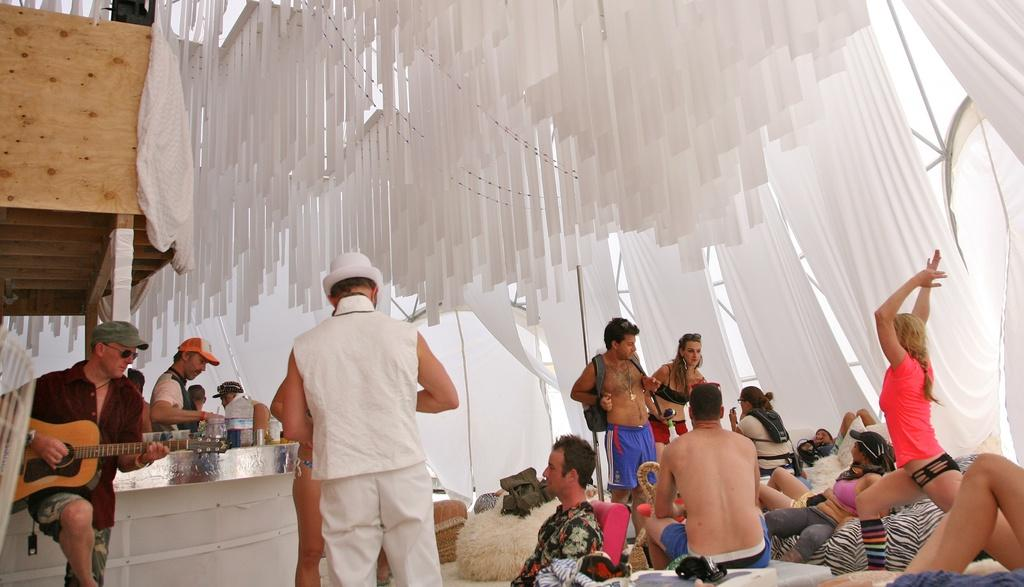How many people are in the image? There are many people in the image. What are some of the people doing in the image? Some people are sitting, while others are standing. Can you describe any specific activity being performed by someone in the image? A man is playing a guitar. What object can be seen in the image that might be used for serving or eating? There is a table in the image. What is the man near the table doing? A man is serving items on the table. Where is the sink located in the image? There is no sink present in the image. Can you tell me how many friends are visible in the image? The term "friends" is not mentioned in the provided facts, so it is not possible to determine the number of friends in the image. 